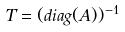Convert formula to latex. <formula><loc_0><loc_0><loc_500><loc_500>T = ( d i a g ( A ) ) ^ { - 1 }</formula> 